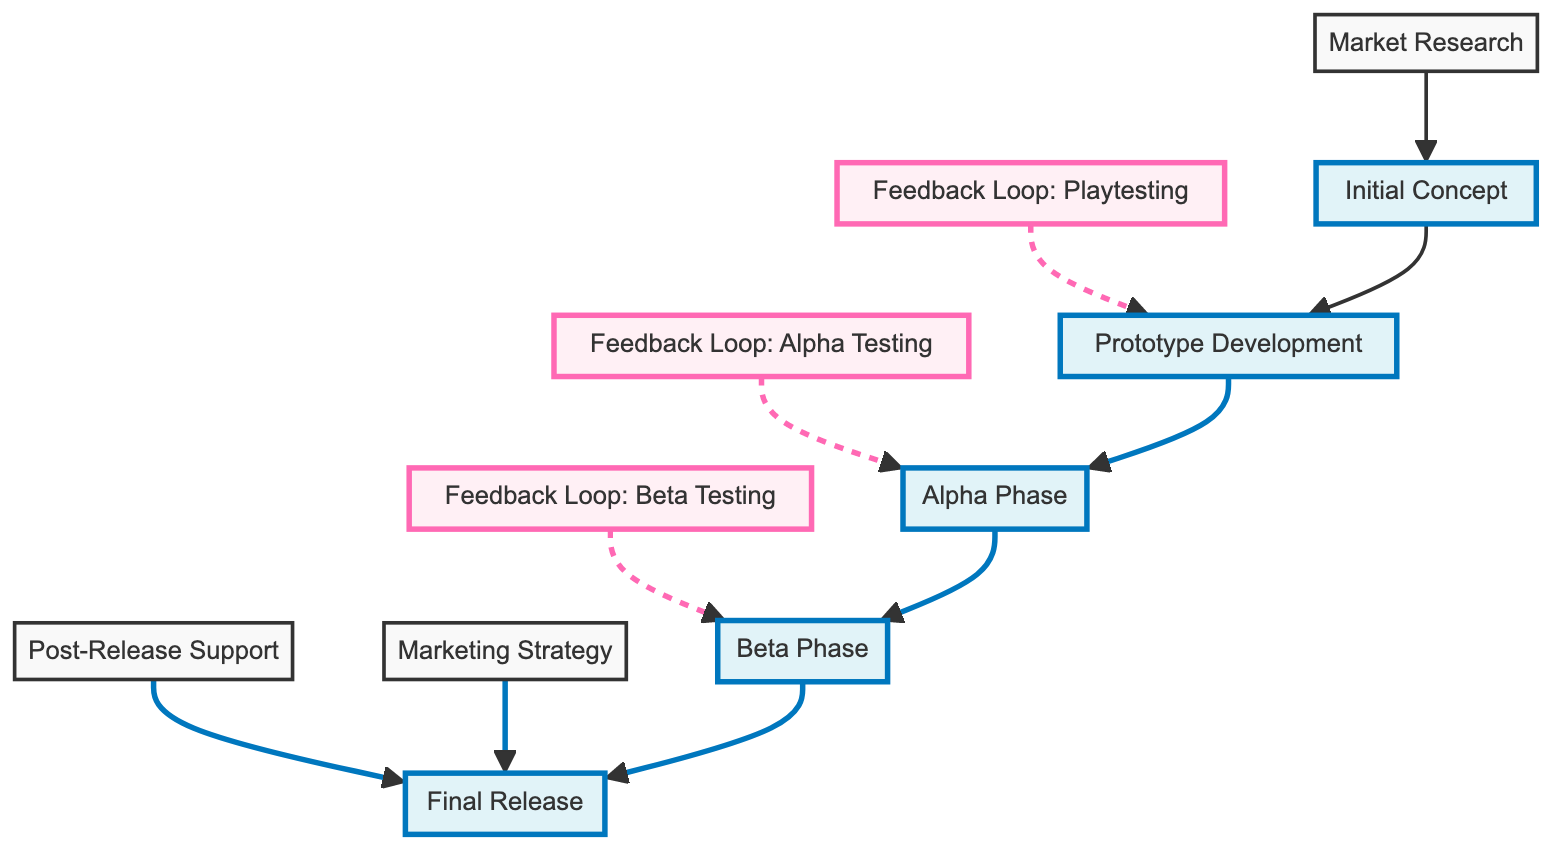What is the first step in the game development process? The diagram starts with "Initial Concept" as the first node representing the game idea and core mechanics.
Answer: Initial Concept How many feedback loops are identified in the diagram? The diagram shows three feedback loops: Playtesting, Alpha Testing, and Beta Testing. Counting these gives a total of three feedback loops.
Answer: 3 Which milestone follows after the Alpha Phase? After the Alpha Phase, the diagram leads directly to the Beta Phase as the next milestone before the final release.
Answer: Beta Phase What does the Marketing Strategy influence in the diagram? The diagram shows that the Marketing Strategy influences the Final Release, indicating its importance before launching the game.
Answer: Final Release In which phase is player feedback collected extensively? The diagram specifies that extensive feedback from players is gathered during the Beta Phase, as indicated in the associated feedback loop.
Answer: Beta Phase What is the significance of the Post-Release Support node? The Post-Release Support node follows the Final Release and indicates the ongoing process of addressing player issues and updates after launch.
Answer: Ongoing support How does the Initial Concept relate to Market Research? The diagram indicates that Market Research feeds back into refining the Initial Concept. This highlights the iterative process between understanding the market and defining the game idea.
Answer: Refinement Which milestone comes before the Final Release? The Beta Phase comes directly before the Final Release in the diagram, making it a crucial step in the game development process.
Answer: Beta Phase What type of flow is represented in the "Feedback Loop: Playtesting"? The diagram indicates a feedback loop, which is represented by a dashed line, showing that feedback is cyclical and not a linear path.
Answer: Cyclical feedback 